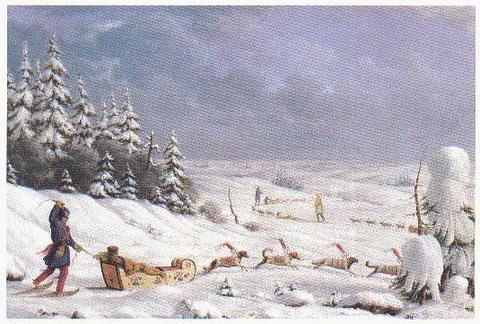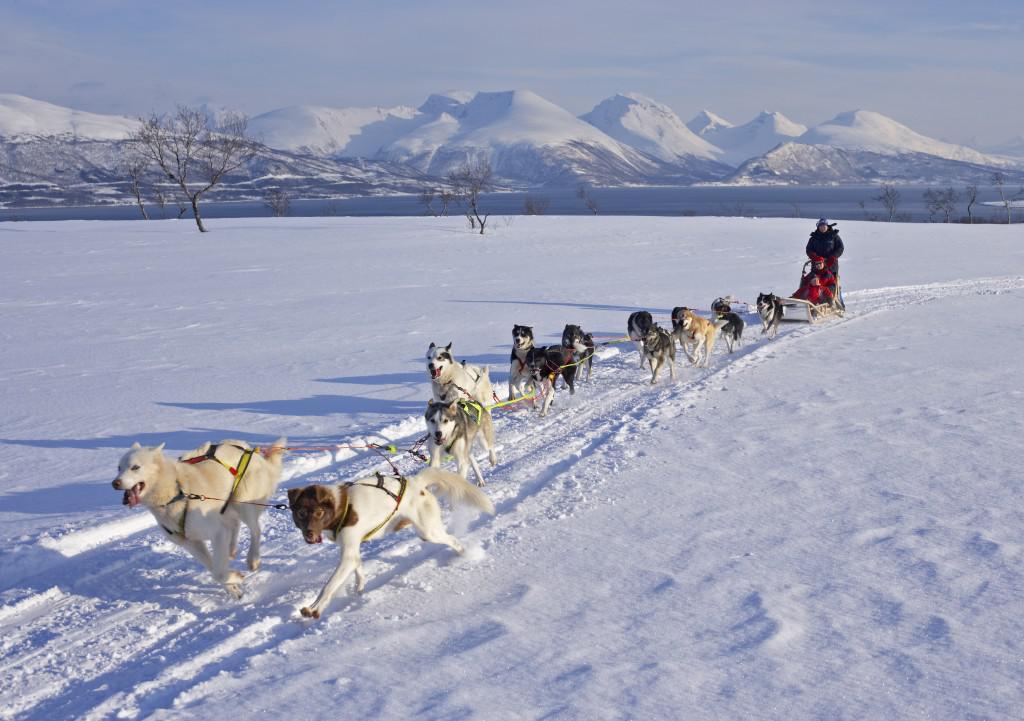The first image is the image on the left, the second image is the image on the right. For the images displayed, is the sentence "There are trees visible in both images." factually correct? Answer yes or no. Yes. The first image is the image on the left, the second image is the image on the right. Examine the images to the left and right. Is the description "One image shows at least one sled dog team moving horizontally rightward, and the other image shows at least one dog team moving forward at some angle." accurate? Answer yes or no. Yes. 